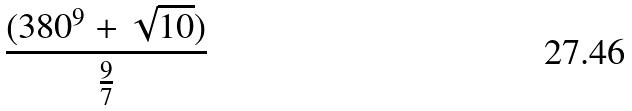Convert formula to latex. <formula><loc_0><loc_0><loc_500><loc_500>\frac { ( 3 8 0 ^ { 9 } + \sqrt { 1 0 } ) } { \frac { 9 } { 7 } }</formula> 